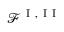<formula> <loc_0><loc_0><loc_500><loc_500>\mathcal { F } ^ { I , I I }</formula> 